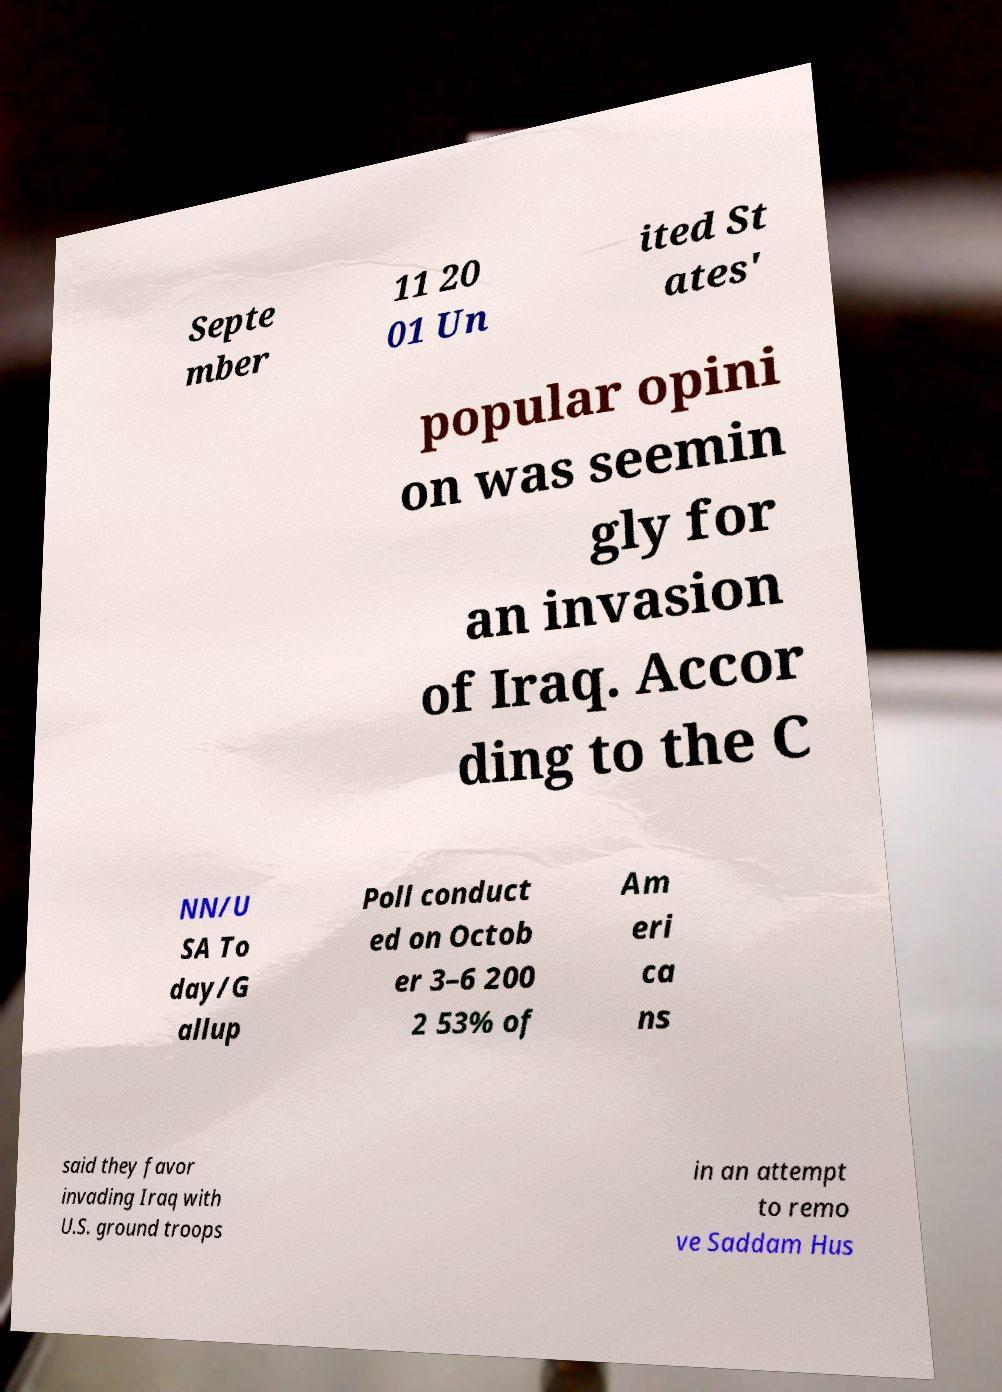There's text embedded in this image that I need extracted. Can you transcribe it verbatim? Septe mber 11 20 01 Un ited St ates' popular opini on was seemin gly for an invasion of Iraq. Accor ding to the C NN/U SA To day/G allup Poll conduct ed on Octob er 3–6 200 2 53% of Am eri ca ns said they favor invading Iraq with U.S. ground troops in an attempt to remo ve Saddam Hus 